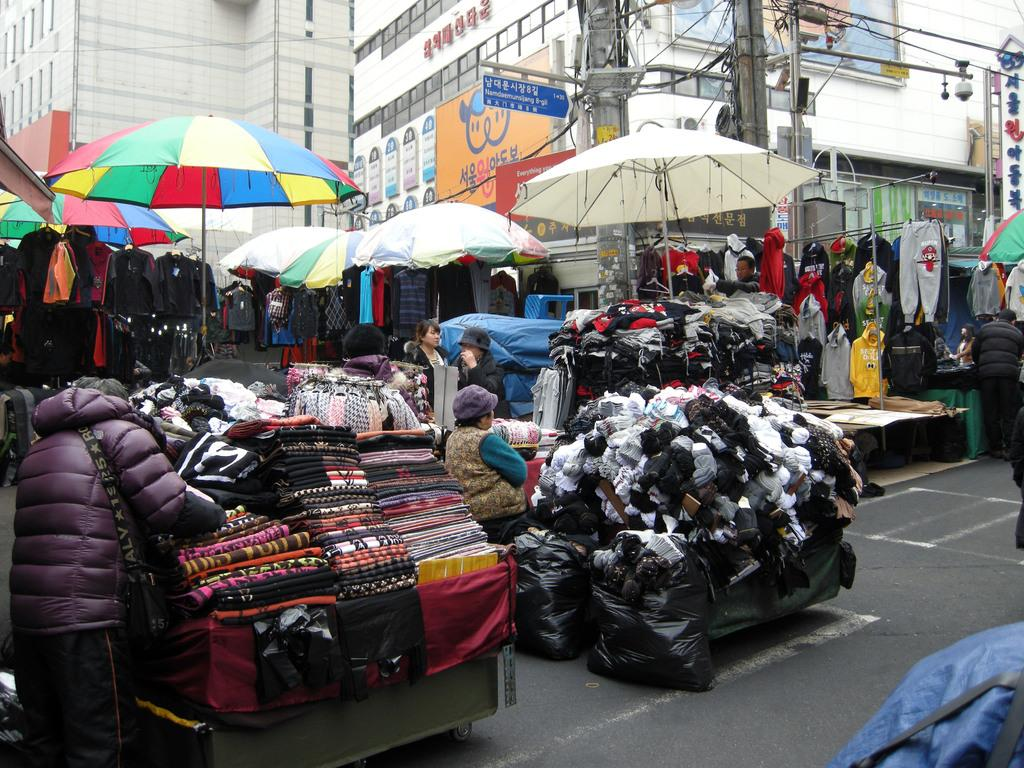What type of location is depicted in the image? The image appears to depict a market. What type of items can be seen in the market? Clothes are visible in the image. What objects are present to provide shade or protection from the elements? Umbrellas are present in the image. What can be seen in the distance behind the market? There are buildings in the background of the image. What type of signage is present in the image? There are hoardings in the middle of the image. Where is the nest of the bird located in the image? There is no nest of a bird present in the image. What type of waste can be seen in the image? There is no waste visible in the image; it depicts a market with various items and objects. 